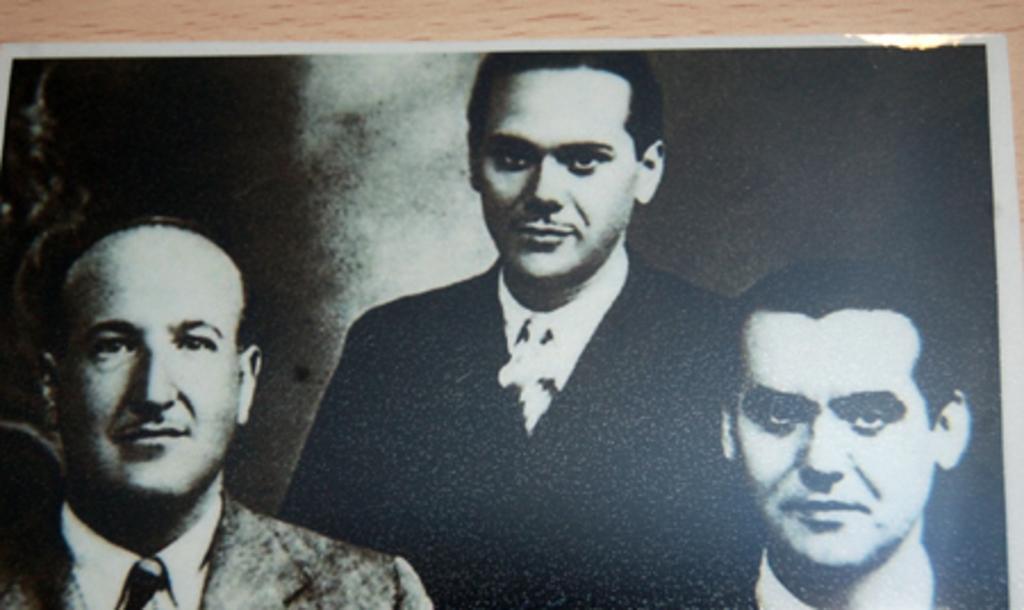How would you summarize this image in a sentence or two? In this picture we can observe three members. All of them were men. This is a black and white image. 